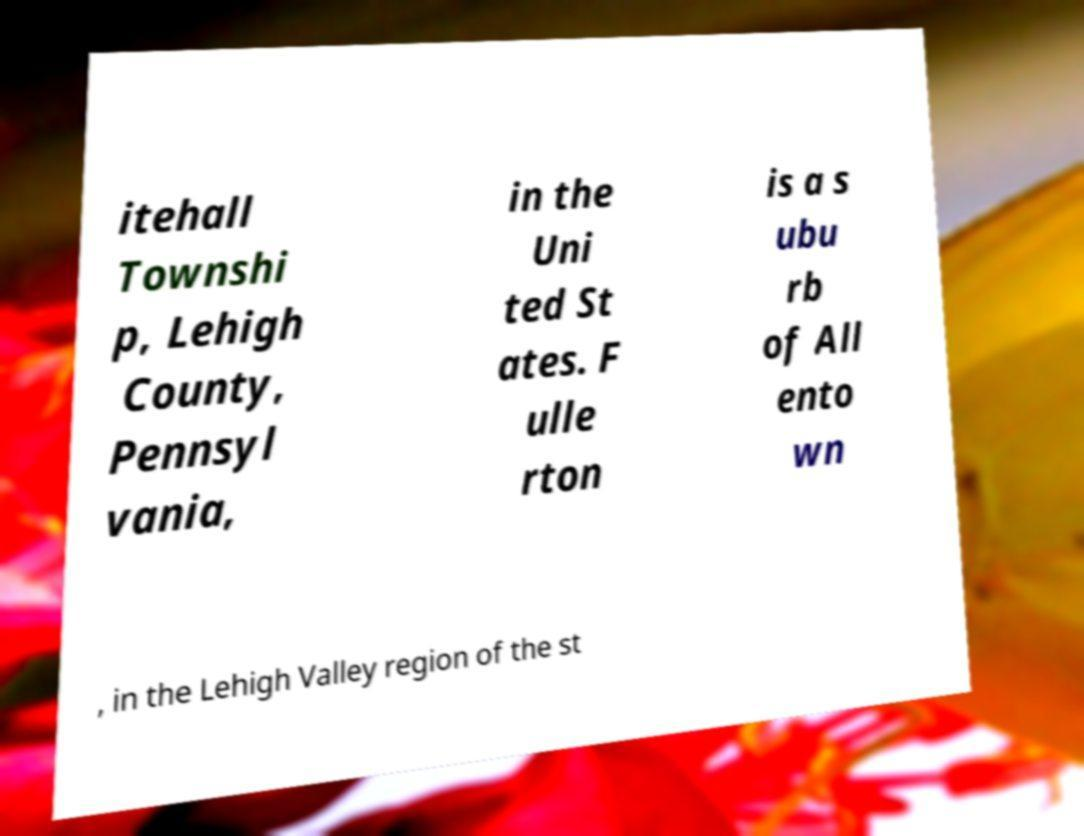Can you read and provide the text displayed in the image?This photo seems to have some interesting text. Can you extract and type it out for me? itehall Townshi p, Lehigh County, Pennsyl vania, in the Uni ted St ates. F ulle rton is a s ubu rb of All ento wn , in the Lehigh Valley region of the st 